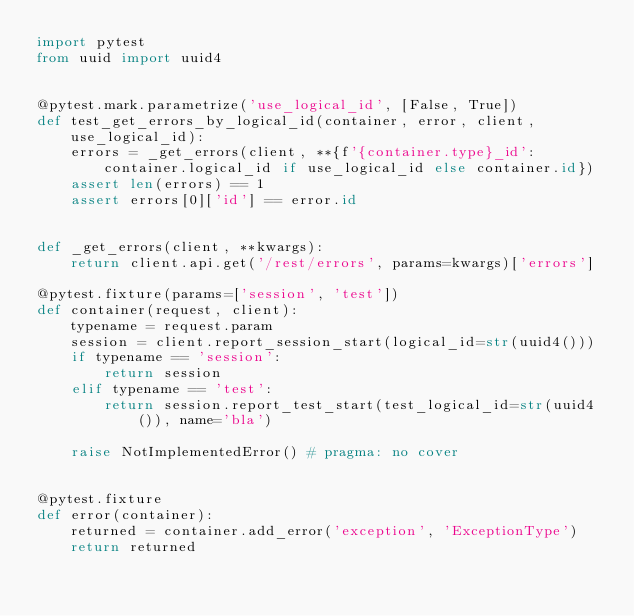Convert code to text. <code><loc_0><loc_0><loc_500><loc_500><_Python_>import pytest
from uuid import uuid4


@pytest.mark.parametrize('use_logical_id', [False, True])
def test_get_errors_by_logical_id(container, error, client, use_logical_id):
    errors = _get_errors(client, **{f'{container.type}_id': container.logical_id if use_logical_id else container.id})
    assert len(errors) == 1
    assert errors[0]['id'] == error.id


def _get_errors(client, **kwargs):
    return client.api.get('/rest/errors', params=kwargs)['errors']

@pytest.fixture(params=['session', 'test'])
def container(request, client):
    typename = request.param
    session = client.report_session_start(logical_id=str(uuid4()))
    if typename == 'session':
        return session
    elif typename == 'test':
        return session.report_test_start(test_logical_id=str(uuid4()), name='bla')

    raise NotImplementedError() # pragma: no cover


@pytest.fixture
def error(container):
    returned = container.add_error('exception', 'ExceptionType')
    return returned
</code> 